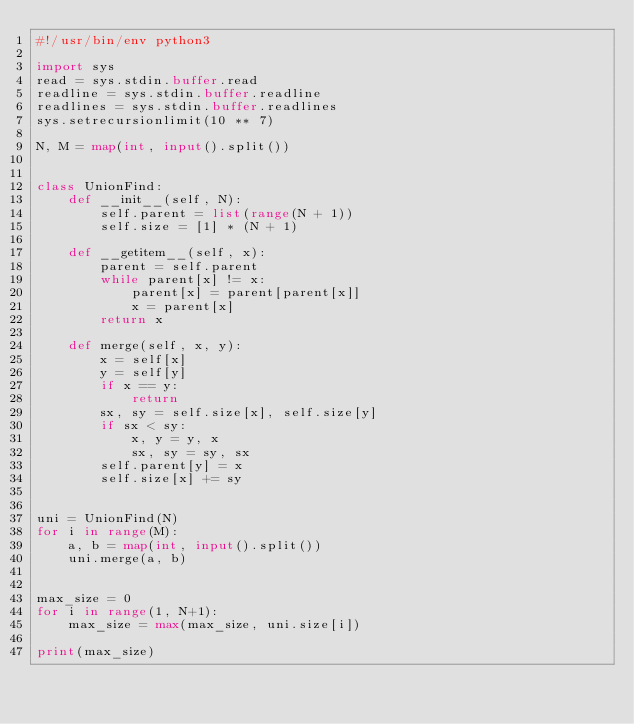<code> <loc_0><loc_0><loc_500><loc_500><_Python_>#!/usr/bin/env python3

import sys
read = sys.stdin.buffer.read
readline = sys.stdin.buffer.readline
readlines = sys.stdin.buffer.readlines
sys.setrecursionlimit(10 ** 7)

N, M = map(int, input().split())


class UnionFind:
    def __init__(self, N):
        self.parent = list(range(N + 1))
        self.size = [1] * (N + 1)

    def __getitem__(self, x):
        parent = self.parent
        while parent[x] != x:
            parent[x] = parent[parent[x]]
            x = parent[x]
        return x

    def merge(self, x, y):
        x = self[x]
        y = self[y]
        if x == y:
            return
        sx, sy = self.size[x], self.size[y]
        if sx < sy:
            x, y = y, x
            sx, sy = sy, sx
        self.parent[y] = x
        self.size[x] += sy


uni = UnionFind(N)
for i in range(M):
    a, b = map(int, input().split())
    uni.merge(a, b)


max_size = 0
for i in range(1, N+1):
    max_size = max(max_size, uni.size[i])

print(max_size)
</code> 